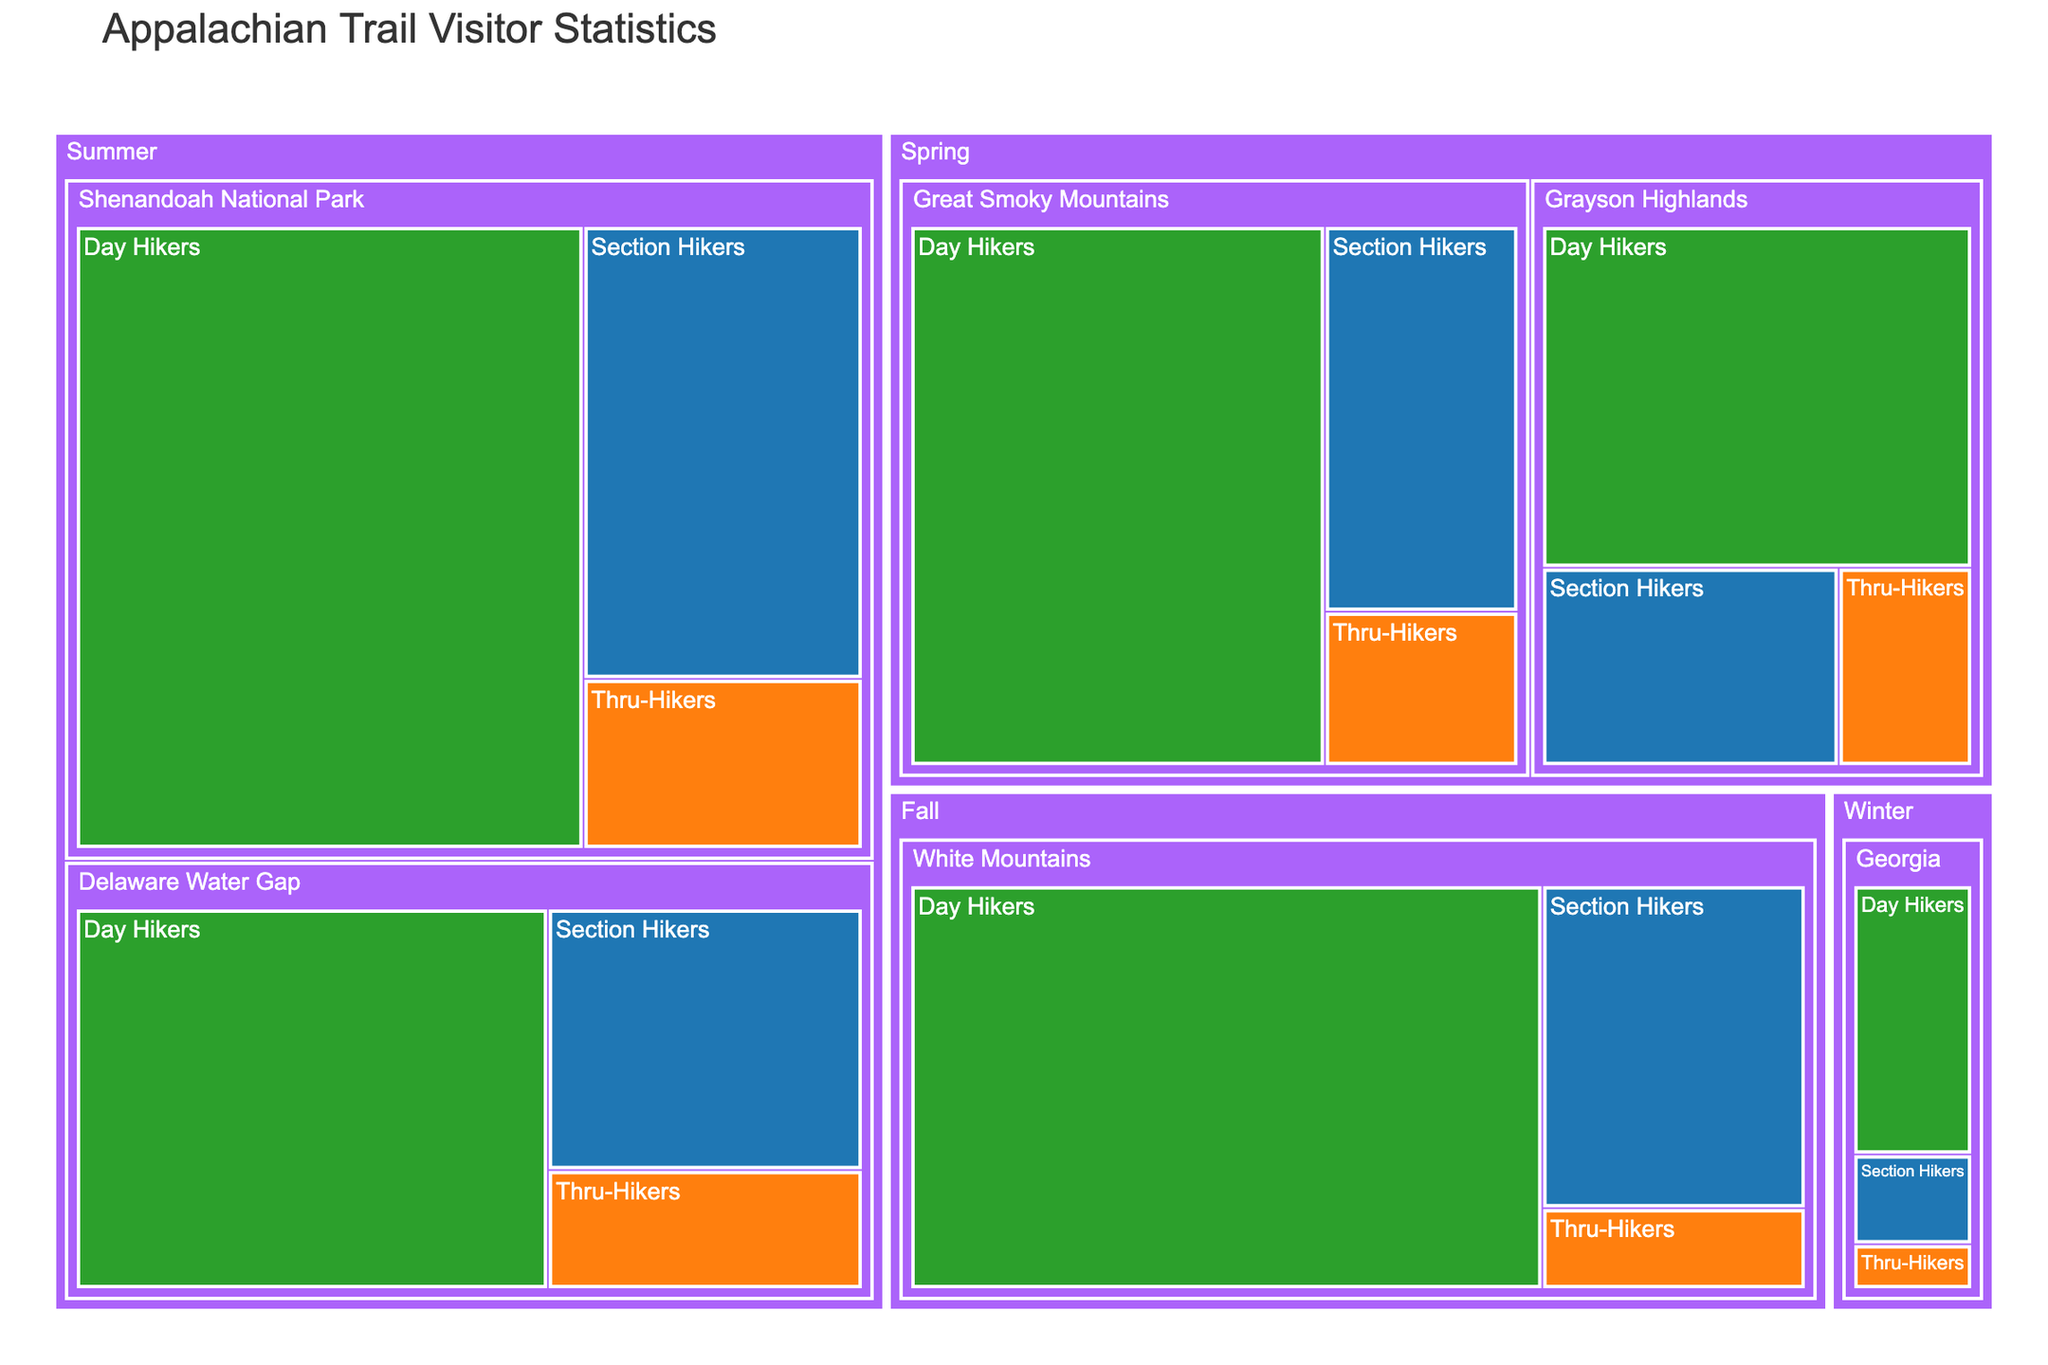What's the highest number of visitors for any single section? Look for the section with the highest visitor count. The Shenandoah National Park in summer for Day Hikers has the highest number of visitors, showing 20,000 visitors.
Answer: 20,000 Which season has the largest number of visitors overall? Sum all the visitor numbers for each season. The seasons have the following totals: Spring (3 sections) = 23,800, Summer (2 sections) = 51,000, Fall (1 section) = 25,500, Winter (1 section) = 4,500. Summer has the largest number of visitors overall, 51,000 visitors.
Answer: Summer How many visitors do Day Hikers have in total? Sum the visitor counts for all Day Hiker entries. The numbers are: 15,000 (Great Smoky Mountains, Spring) + 20,000 (Shenandoah National Park, Summer) + 18,000 (White Mountains, Fall) + 3,000 (Georgia, Winter) + 10,000 (Grayson Highlands, Spring) + 12,000 (Delaware Water Gap, Summer) = 78,000.
Answer: 78,000 What is the difference in visitor numbers between Thru-Hikers and Section Hikers in the Shenandoah National Park in summer? Find the difference by subtracting the visitors of Thru-Hikers (3,000) from the visitors of Section Hikers (8,000): 8,000 - 3,000 = 5,000.
Answer: 5,000 Which section has the least number of visitors during winter? Look at the winter sections and find the one with the least visitors. The data shows Georgia with 3,000, 1,000, and 500 for Day Hikers, Section Hikers, and Thru-Hikers respectively. The Thru-Hikers have the least number of visitors during winter with 500 visitors.
Answer: Georgia for Thru-Hikers Which hiker type has the fewest visitors across all sections and seasons? Sum the visitors for each hiker type across all sections and seasons: Day Hiker (78,000), Section Hiker (30,500), Thru-Hiker (11,300). Thru-Hikers have the fewest visitors with 11,300 visitors.
Answer: Thru-Hikers What is the average number of visitors for Day Hikers in the Spring season? Add up all the visitors for Day Hikers in Spring sections and divide by the number of sections: (15,000 + 10,000) / 2 = 12,500.
Answer: 12,500 Compare the visitors of Day Hikers in the Great Smoky Mountains and Grayson Highlands during Spring. Which section has more visitors? Compare the visitors of the two sections. The Great Smoky Mountains has 15,000 while Grayson Highlands has 10,000. The Great Smoky Mountains has more visitors.
Answer: Great Smoky Mountains How many more visitors do Section Hikers have in Shenandoah National Park during the summer compared to all visitors in Georgia during the winter? Subtract the total visitors in Georgia during winter (3,000 + 1,000 + 500 = 4,500) from Section Hikers' count in Shenandoah National Park (8,000): 8,000 - 4,500 = 3,500.
Answer: 3,500 